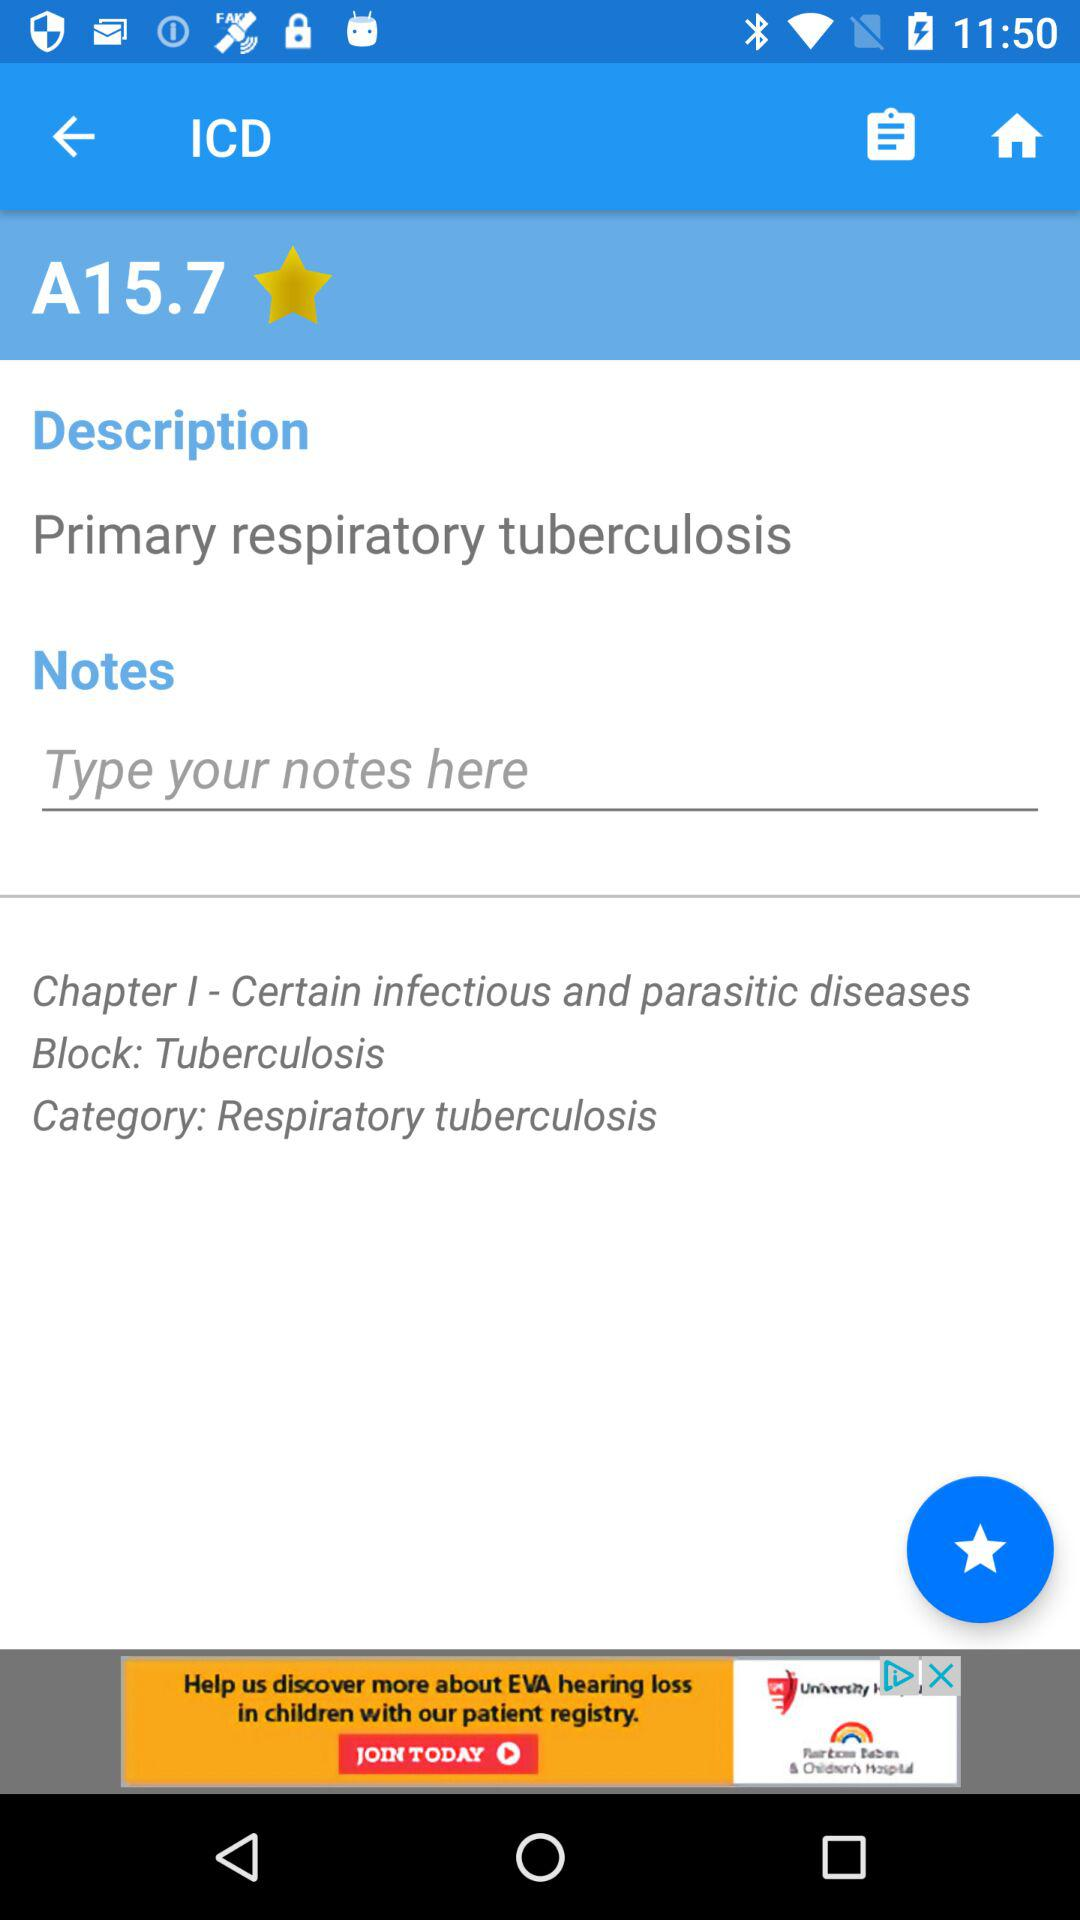What is the "Description"? The description is "Primary respiratory tuberculosis". 